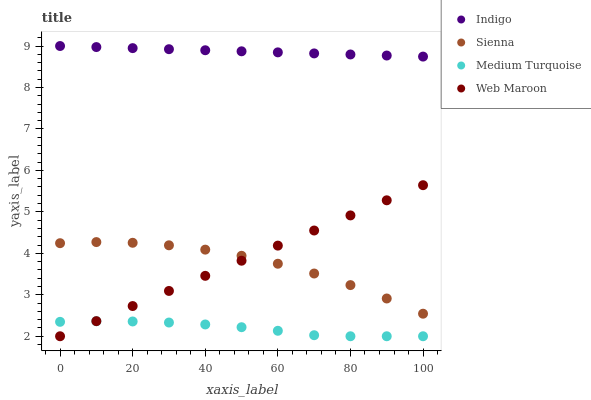Does Medium Turquoise have the minimum area under the curve?
Answer yes or no. Yes. Does Indigo have the maximum area under the curve?
Answer yes or no. Yes. Does Web Maroon have the minimum area under the curve?
Answer yes or no. No. Does Web Maroon have the maximum area under the curve?
Answer yes or no. No. Is Web Maroon the smoothest?
Answer yes or no. Yes. Is Sienna the roughest?
Answer yes or no. Yes. Is Indigo the smoothest?
Answer yes or no. No. Is Indigo the roughest?
Answer yes or no. No. Does Web Maroon have the lowest value?
Answer yes or no. Yes. Does Indigo have the lowest value?
Answer yes or no. No. Does Indigo have the highest value?
Answer yes or no. Yes. Does Web Maroon have the highest value?
Answer yes or no. No. Is Web Maroon less than Indigo?
Answer yes or no. Yes. Is Sienna greater than Medium Turquoise?
Answer yes or no. Yes. Does Web Maroon intersect Medium Turquoise?
Answer yes or no. Yes. Is Web Maroon less than Medium Turquoise?
Answer yes or no. No. Is Web Maroon greater than Medium Turquoise?
Answer yes or no. No. Does Web Maroon intersect Indigo?
Answer yes or no. No. 